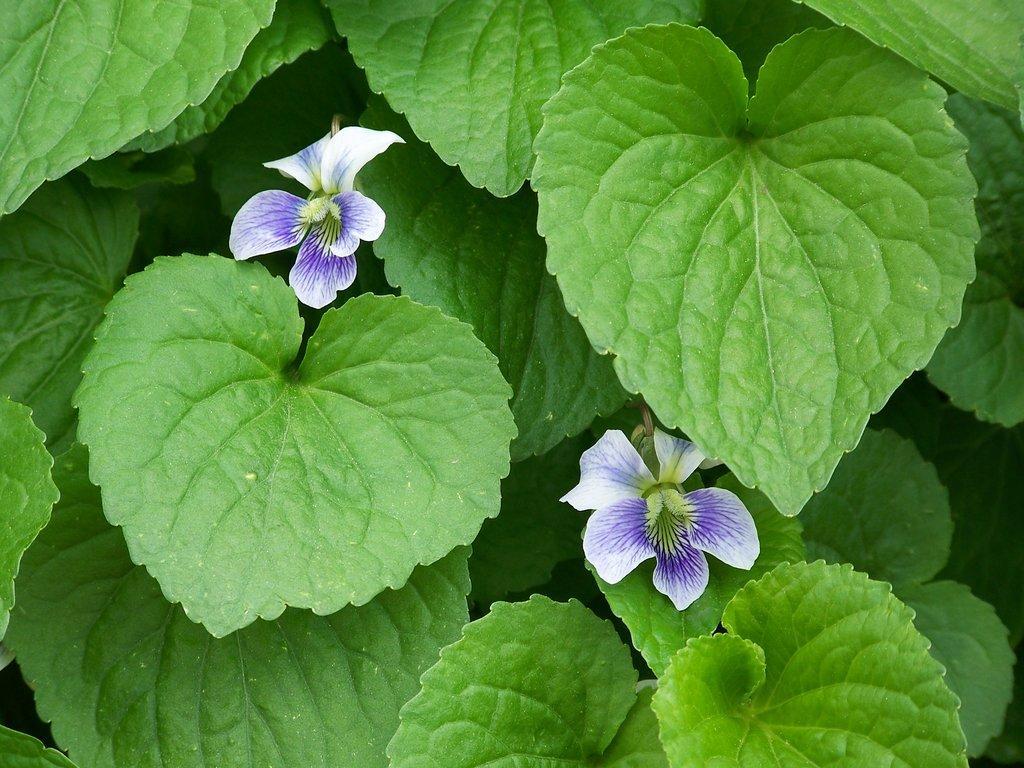Please provide a concise description of this image. In this picture we can see green leaves and two flowers. 